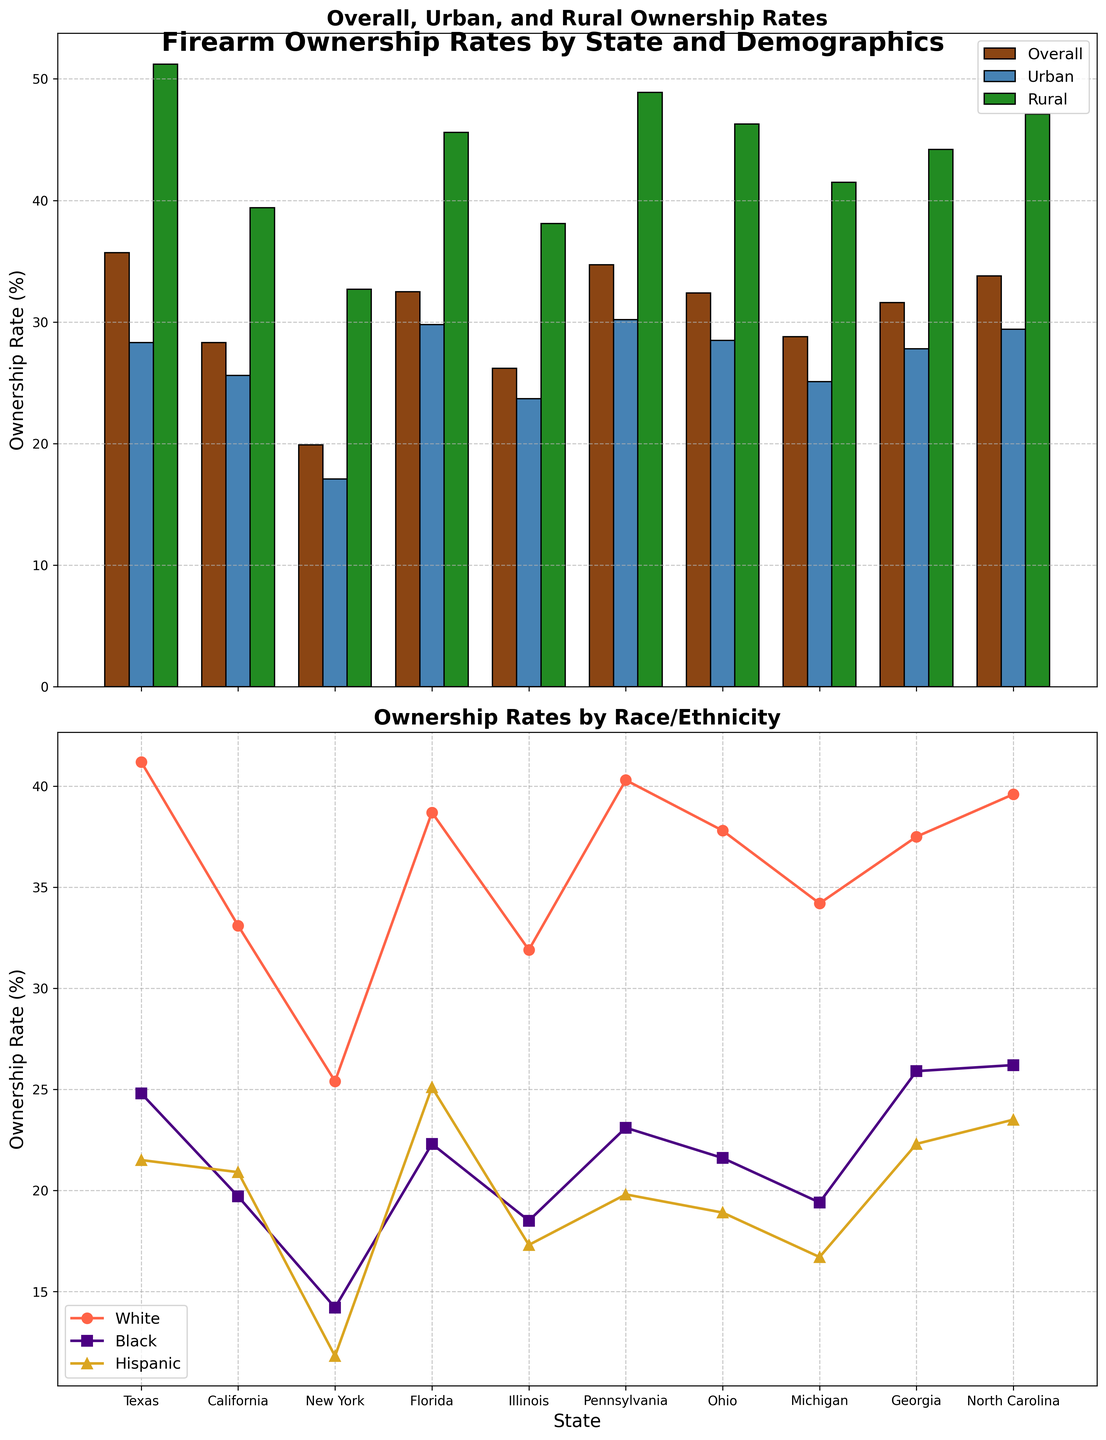What's the overall firearm ownership rate in Texas? Locate Texas in the "Overall Ownership Rate" bar in the top subplot and read the value.
Answer: 35.7 Which state has the lowest firearm ownership rate among rural populations? Examine the "Rural" bars in the top subplot and find the bar with the lowest value.
Answer: New York How does the firearm ownership rate for White residents in Ohio compare to that in Michigan? Compare the plot markers for White residents in Ohio and Michigan in the bottom subplot. Ohio has a value of 37.8, and Michigan has 34.2. Thus, Ohio is higher.
Answer: Ohio is higher What is the difference in firearm ownership rates between Urban and Rural populations in Pennsylvania? Subtract the Urban ownership rate from the Rural ownership rate in Pennsylvania. Rural (48.9) - Urban (30.2) = 18.7.
Answer: 18.7 In which state do Hispanic residents have the lowest firearm ownership rate, and what is it? Locate the state with the lowest plot marker for Hispanic residents in the bottom subplot and read the value.
Answer: New York, 11.8 Among Black residents, which state has the highest firearm ownership rate? Identify the highest plot marker for Black residents in the bottom subplot.
Answer: North Carolina What is the average firearm ownership rate among Urban populations in the states shown? Sum the Urban ownership rates from all states and divide by the number of states: (28.3 + 25.6 + 17.1 + 29.8 + 23.7 + 30.2 + 28.5 + 25.1 + 27.8 + 29.4) / 10 = (265.5 / 10) = 26.55.
Answer: 26.55 Compare the overall firearm ownership rates between Pennsylvania and Florida. Check the "Overall Ownership Rate" bars for Pennsylvania and Florida. Pennsylvania is 34.7, and Florida is 32.5.
Answer: Pennsylvania is higher Is there any state where the firearm ownership rate in urban areas exceeds that in rural areas? Compare the Urban and Rural bars for each state in the top subplot to see if any Urban bars exceed Rural bars.
Answer: No 